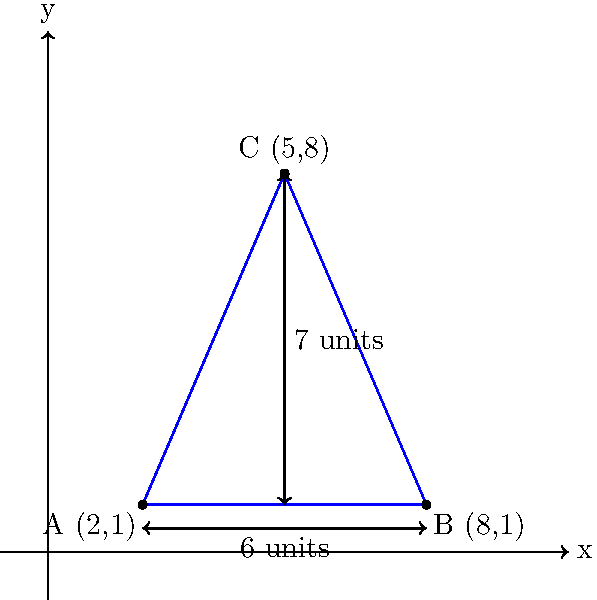Evel Knievel is planning his next death-defying motorcycle jump, and you're in charge of safety. A triangular safety net needs to be positioned below the jump. The net's corners are at coordinates A(2,1), B(8,1), and C(5,8) on a coordinate plane where each unit represents 10 feet. Calculate the area of the safety net in square feet. Let's approach this step-by-step:

1) We can calculate the area of a triangle using the formula:
   $$ \text{Area} = \frac{1}{2}|x_1(y_2 - y_3) + x_2(y_3 - y_1) + x_3(y_1 - y_2)| $$
   where $(x_1,y_1)$, $(x_2,y_2)$, and $(x_3,y_3)$ are the coordinates of the three vertices.

2) We have:
   A(2,1), B(8,1), C(5,8)
   So, $(x_1,y_1) = (2,1)$, $(x_2,y_2) = (8,1)$, $(x_3,y_3) = (5,8)$

3) Let's substitute these into our formula:
   $$ \text{Area} = \frac{1}{2}|2(1 - 8) + 8(8 - 1) + 5(1 - 1)| $$

4) Simplify:
   $$ \text{Area} = \frac{1}{2}|2(-7) + 8(7) + 5(0)| $$
   $$ \text{Area} = \frac{1}{2}|-14 + 56 + 0| $$
   $$ \text{Area} = \frac{1}{2}|42| $$
   $$ \text{Area} = \frac{1}{2}(42) = 21 $$

5) Remember, each unit represents 10 feet, so we need to multiply our result by $10^2 = 100$:
   $$ \text{Actual Area} = 21 * 100 = 2100 \text{ square feet} $$

Thus, the area of the safety net is 2100 square feet.
Answer: 2100 square feet 